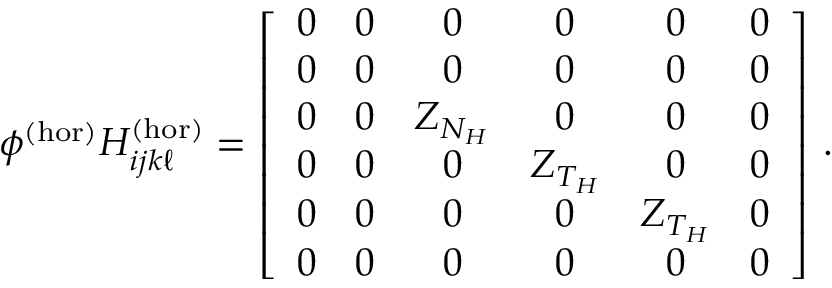<formula> <loc_0><loc_0><loc_500><loc_500>\phi ^ { ( h o r ) } H _ { i j k \ell } ^ { ( h o r ) } = \left [ \begin{array} { c c c c c c } { 0 } & { 0 } & { 0 } & { 0 } & { 0 } & { 0 } \\ { 0 } & { 0 } & { 0 } & { 0 } & { 0 } & { 0 } \\ { 0 } & { 0 } & { Z _ { N _ { H } } } & { 0 } & { 0 } & { 0 } \\ { 0 } & { 0 } & { 0 } & { Z _ { T _ { H } } } & { 0 } & { 0 } \\ { 0 } & { 0 } & { 0 } & { 0 } & { Z _ { T _ { H } } } & { 0 } \\ { 0 } & { 0 } & { 0 } & { 0 } & { 0 } & { 0 } \end{array} \right ] \, .</formula> 